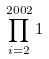Convert formula to latex. <formula><loc_0><loc_0><loc_500><loc_500>\prod _ { i = 2 } ^ { 2 0 0 2 } 1</formula> 